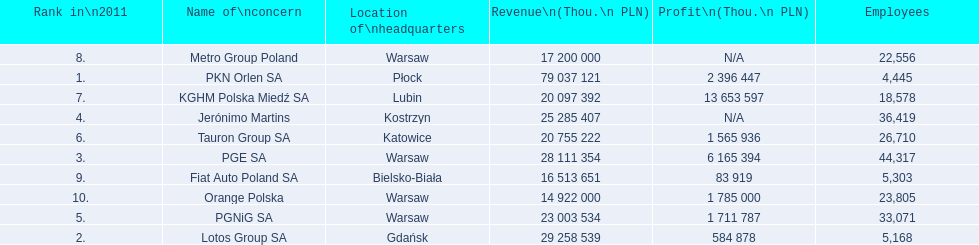What is the number of employees that work for pkn orlen sa in poland? 4,445. What number of employees work for lotos group sa? 5,168. How many people work for pgnig sa? 33,071. 